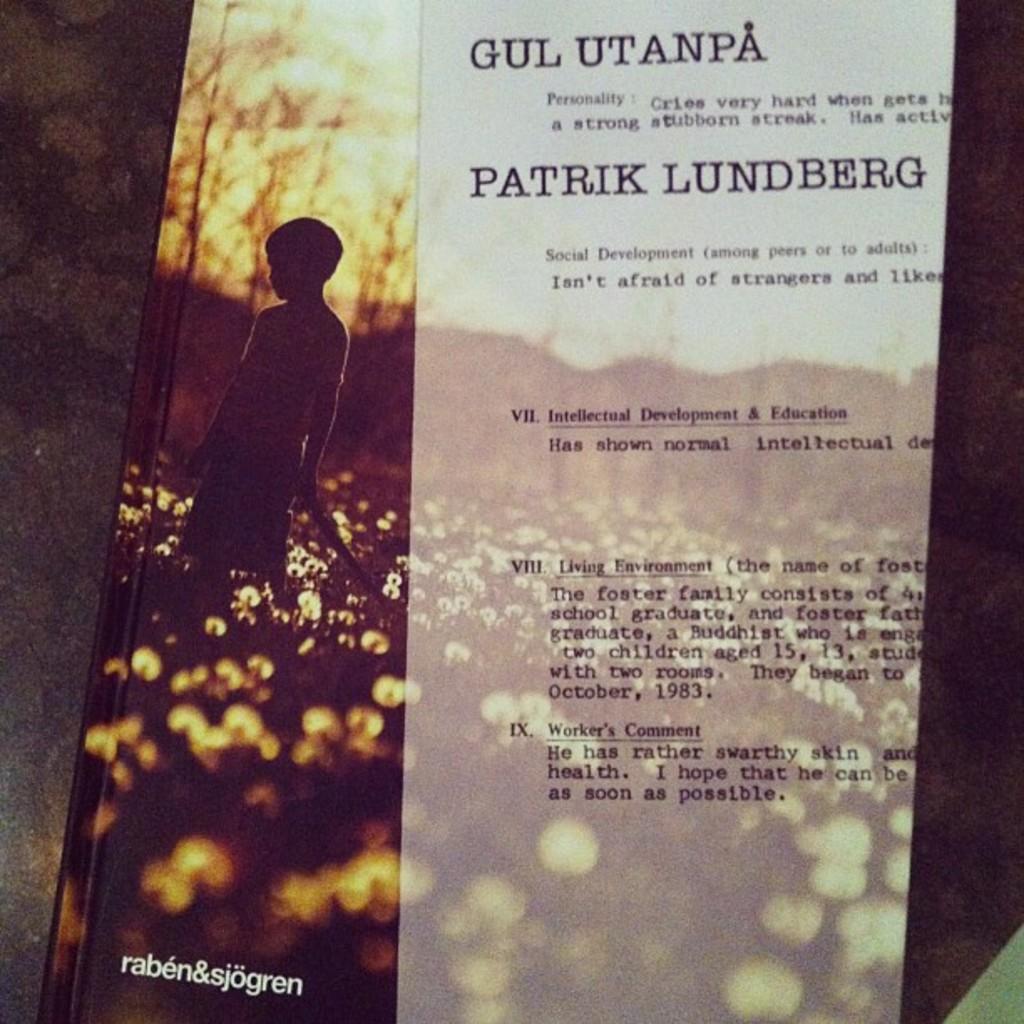Was patrik the author of the magazine?
Your response must be concise. Yes. 